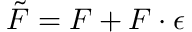Convert formula to latex. <formula><loc_0><loc_0><loc_500><loc_500>\tilde { F } = F + F \cdot \epsilon</formula> 